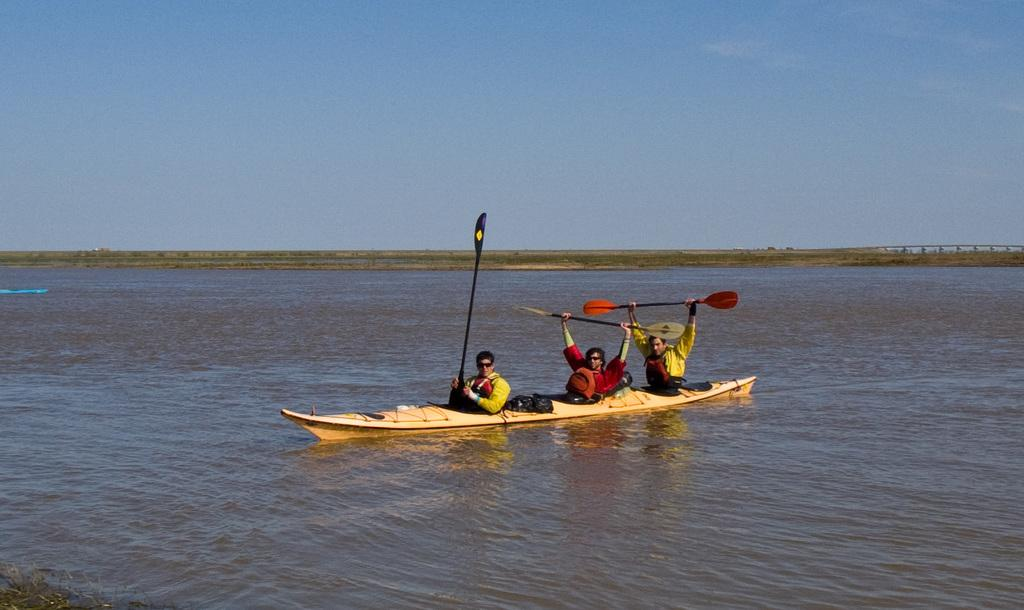How many people are in the image? There are three persons in the image. What are the persons doing in the image? The persons are sitting on a boat. Where is the boat located in the image? The boat is on the water. What are the persons holding in the image? The persons are holding paddles. What can be seen in the background of the image? There is sky visible in the background of the image. What type of magic trick is the person on the left performing in the image? There is no magic trick or any indication of magic in the image; the persons are simply sitting on a boat and holding paddles. 